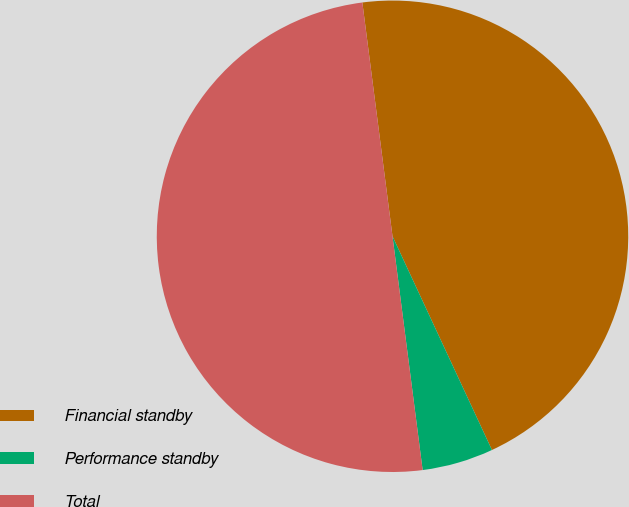Convert chart. <chart><loc_0><loc_0><loc_500><loc_500><pie_chart><fcel>Financial standby<fcel>Performance standby<fcel>Total<nl><fcel>45.11%<fcel>4.89%<fcel>50.0%<nl></chart> 